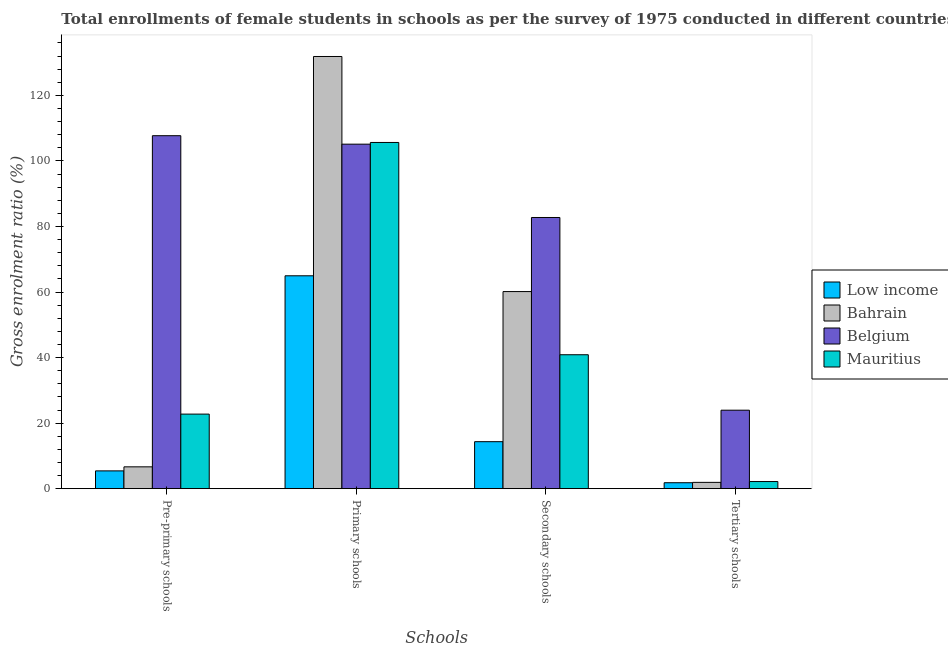How many groups of bars are there?
Give a very brief answer. 4. How many bars are there on the 1st tick from the left?
Your answer should be very brief. 4. How many bars are there on the 3rd tick from the right?
Make the answer very short. 4. What is the label of the 4th group of bars from the left?
Provide a succinct answer. Tertiary schools. What is the gross enrolment ratio(female) in pre-primary schools in Low income?
Make the answer very short. 5.43. Across all countries, what is the maximum gross enrolment ratio(female) in secondary schools?
Provide a succinct answer. 82.74. Across all countries, what is the minimum gross enrolment ratio(female) in secondary schools?
Make the answer very short. 14.34. In which country was the gross enrolment ratio(female) in primary schools maximum?
Provide a short and direct response. Bahrain. What is the total gross enrolment ratio(female) in tertiary schools in the graph?
Make the answer very short. 29.86. What is the difference between the gross enrolment ratio(female) in tertiary schools in Belgium and that in Bahrain?
Give a very brief answer. 22.02. What is the difference between the gross enrolment ratio(female) in pre-primary schools in Bahrain and the gross enrolment ratio(female) in primary schools in Belgium?
Your answer should be compact. -98.44. What is the average gross enrolment ratio(female) in pre-primary schools per country?
Your answer should be compact. 35.63. What is the difference between the gross enrolment ratio(female) in tertiary schools and gross enrolment ratio(female) in primary schools in Bahrain?
Provide a short and direct response. -129.93. In how many countries, is the gross enrolment ratio(female) in secondary schools greater than 12 %?
Provide a short and direct response. 4. What is the ratio of the gross enrolment ratio(female) in primary schools in Bahrain to that in Low income?
Keep it short and to the point. 2.03. Is the gross enrolment ratio(female) in tertiary schools in Mauritius less than that in Bahrain?
Provide a short and direct response. No. Is the difference between the gross enrolment ratio(female) in pre-primary schools in Mauritius and Low income greater than the difference between the gross enrolment ratio(female) in tertiary schools in Mauritius and Low income?
Provide a succinct answer. Yes. What is the difference between the highest and the second highest gross enrolment ratio(female) in secondary schools?
Give a very brief answer. 22.6. What is the difference between the highest and the lowest gross enrolment ratio(female) in secondary schools?
Offer a very short reply. 68.4. Is it the case that in every country, the sum of the gross enrolment ratio(female) in secondary schools and gross enrolment ratio(female) in primary schools is greater than the sum of gross enrolment ratio(female) in pre-primary schools and gross enrolment ratio(female) in tertiary schools?
Your answer should be very brief. Yes. What does the 2nd bar from the left in Secondary schools represents?
Give a very brief answer. Bahrain. What does the 3rd bar from the right in Secondary schools represents?
Your response must be concise. Bahrain. Is it the case that in every country, the sum of the gross enrolment ratio(female) in pre-primary schools and gross enrolment ratio(female) in primary schools is greater than the gross enrolment ratio(female) in secondary schools?
Make the answer very short. Yes. Does the graph contain any zero values?
Your answer should be very brief. No. Does the graph contain grids?
Ensure brevity in your answer.  No. How many legend labels are there?
Your answer should be very brief. 4. How are the legend labels stacked?
Keep it short and to the point. Vertical. What is the title of the graph?
Ensure brevity in your answer.  Total enrollments of female students in schools as per the survey of 1975 conducted in different countries. What is the label or title of the X-axis?
Your answer should be compact. Schools. What is the Gross enrolment ratio (%) in Low income in Pre-primary schools?
Your answer should be compact. 5.43. What is the Gross enrolment ratio (%) in Bahrain in Pre-primary schools?
Make the answer very short. 6.66. What is the Gross enrolment ratio (%) of Belgium in Pre-primary schools?
Provide a short and direct response. 107.69. What is the Gross enrolment ratio (%) in Mauritius in Pre-primary schools?
Provide a succinct answer. 22.75. What is the Gross enrolment ratio (%) in Low income in Primary schools?
Make the answer very short. 64.95. What is the Gross enrolment ratio (%) in Bahrain in Primary schools?
Make the answer very short. 131.85. What is the Gross enrolment ratio (%) of Belgium in Primary schools?
Offer a terse response. 105.11. What is the Gross enrolment ratio (%) in Mauritius in Primary schools?
Ensure brevity in your answer.  105.62. What is the Gross enrolment ratio (%) in Low income in Secondary schools?
Offer a terse response. 14.34. What is the Gross enrolment ratio (%) of Bahrain in Secondary schools?
Keep it short and to the point. 60.14. What is the Gross enrolment ratio (%) in Belgium in Secondary schools?
Provide a succinct answer. 82.74. What is the Gross enrolment ratio (%) of Mauritius in Secondary schools?
Keep it short and to the point. 40.86. What is the Gross enrolment ratio (%) of Low income in Tertiary schools?
Offer a very short reply. 1.82. What is the Gross enrolment ratio (%) of Bahrain in Tertiary schools?
Keep it short and to the point. 1.92. What is the Gross enrolment ratio (%) of Belgium in Tertiary schools?
Your response must be concise. 23.95. What is the Gross enrolment ratio (%) of Mauritius in Tertiary schools?
Offer a terse response. 2.18. Across all Schools, what is the maximum Gross enrolment ratio (%) in Low income?
Offer a very short reply. 64.95. Across all Schools, what is the maximum Gross enrolment ratio (%) of Bahrain?
Your response must be concise. 131.85. Across all Schools, what is the maximum Gross enrolment ratio (%) in Belgium?
Ensure brevity in your answer.  107.69. Across all Schools, what is the maximum Gross enrolment ratio (%) of Mauritius?
Your response must be concise. 105.62. Across all Schools, what is the minimum Gross enrolment ratio (%) in Low income?
Your answer should be compact. 1.82. Across all Schools, what is the minimum Gross enrolment ratio (%) of Bahrain?
Ensure brevity in your answer.  1.92. Across all Schools, what is the minimum Gross enrolment ratio (%) in Belgium?
Your answer should be compact. 23.95. Across all Schools, what is the minimum Gross enrolment ratio (%) in Mauritius?
Provide a succinct answer. 2.18. What is the total Gross enrolment ratio (%) in Low income in the graph?
Ensure brevity in your answer.  86.53. What is the total Gross enrolment ratio (%) in Bahrain in the graph?
Provide a short and direct response. 200.58. What is the total Gross enrolment ratio (%) of Belgium in the graph?
Provide a short and direct response. 319.48. What is the total Gross enrolment ratio (%) of Mauritius in the graph?
Your response must be concise. 171.41. What is the difference between the Gross enrolment ratio (%) of Low income in Pre-primary schools and that in Primary schools?
Make the answer very short. -59.52. What is the difference between the Gross enrolment ratio (%) in Bahrain in Pre-primary schools and that in Primary schools?
Offer a terse response. -125.19. What is the difference between the Gross enrolment ratio (%) in Belgium in Pre-primary schools and that in Primary schools?
Provide a succinct answer. 2.58. What is the difference between the Gross enrolment ratio (%) in Mauritius in Pre-primary schools and that in Primary schools?
Offer a terse response. -82.87. What is the difference between the Gross enrolment ratio (%) in Low income in Pre-primary schools and that in Secondary schools?
Offer a very short reply. -8.91. What is the difference between the Gross enrolment ratio (%) of Bahrain in Pre-primary schools and that in Secondary schools?
Make the answer very short. -53.47. What is the difference between the Gross enrolment ratio (%) in Belgium in Pre-primary schools and that in Secondary schools?
Ensure brevity in your answer.  24.95. What is the difference between the Gross enrolment ratio (%) in Mauritius in Pre-primary schools and that in Secondary schools?
Offer a terse response. -18.11. What is the difference between the Gross enrolment ratio (%) in Low income in Pre-primary schools and that in Tertiary schools?
Your answer should be compact. 3.61. What is the difference between the Gross enrolment ratio (%) of Bahrain in Pre-primary schools and that in Tertiary schools?
Give a very brief answer. 4.74. What is the difference between the Gross enrolment ratio (%) in Belgium in Pre-primary schools and that in Tertiary schools?
Provide a succinct answer. 83.74. What is the difference between the Gross enrolment ratio (%) in Mauritius in Pre-primary schools and that in Tertiary schools?
Your response must be concise. 20.57. What is the difference between the Gross enrolment ratio (%) in Low income in Primary schools and that in Secondary schools?
Your answer should be very brief. 50.61. What is the difference between the Gross enrolment ratio (%) in Bahrain in Primary schools and that in Secondary schools?
Your response must be concise. 71.72. What is the difference between the Gross enrolment ratio (%) of Belgium in Primary schools and that in Secondary schools?
Keep it short and to the point. 22.37. What is the difference between the Gross enrolment ratio (%) of Mauritius in Primary schools and that in Secondary schools?
Provide a succinct answer. 64.76. What is the difference between the Gross enrolment ratio (%) of Low income in Primary schools and that in Tertiary schools?
Your answer should be very brief. 63.13. What is the difference between the Gross enrolment ratio (%) in Bahrain in Primary schools and that in Tertiary schools?
Give a very brief answer. 129.93. What is the difference between the Gross enrolment ratio (%) of Belgium in Primary schools and that in Tertiary schools?
Give a very brief answer. 81.16. What is the difference between the Gross enrolment ratio (%) in Mauritius in Primary schools and that in Tertiary schools?
Your answer should be very brief. 103.45. What is the difference between the Gross enrolment ratio (%) of Low income in Secondary schools and that in Tertiary schools?
Offer a terse response. 12.52. What is the difference between the Gross enrolment ratio (%) of Bahrain in Secondary schools and that in Tertiary schools?
Provide a succinct answer. 58.21. What is the difference between the Gross enrolment ratio (%) of Belgium in Secondary schools and that in Tertiary schools?
Ensure brevity in your answer.  58.79. What is the difference between the Gross enrolment ratio (%) in Mauritius in Secondary schools and that in Tertiary schools?
Your answer should be compact. 38.69. What is the difference between the Gross enrolment ratio (%) in Low income in Pre-primary schools and the Gross enrolment ratio (%) in Bahrain in Primary schools?
Offer a terse response. -126.43. What is the difference between the Gross enrolment ratio (%) in Low income in Pre-primary schools and the Gross enrolment ratio (%) in Belgium in Primary schools?
Make the answer very short. -99.68. What is the difference between the Gross enrolment ratio (%) in Low income in Pre-primary schools and the Gross enrolment ratio (%) in Mauritius in Primary schools?
Your answer should be very brief. -100.19. What is the difference between the Gross enrolment ratio (%) in Bahrain in Pre-primary schools and the Gross enrolment ratio (%) in Belgium in Primary schools?
Keep it short and to the point. -98.44. What is the difference between the Gross enrolment ratio (%) in Bahrain in Pre-primary schools and the Gross enrolment ratio (%) in Mauritius in Primary schools?
Provide a succinct answer. -98.96. What is the difference between the Gross enrolment ratio (%) of Belgium in Pre-primary schools and the Gross enrolment ratio (%) of Mauritius in Primary schools?
Your answer should be compact. 2.06. What is the difference between the Gross enrolment ratio (%) in Low income in Pre-primary schools and the Gross enrolment ratio (%) in Bahrain in Secondary schools?
Keep it short and to the point. -54.71. What is the difference between the Gross enrolment ratio (%) in Low income in Pre-primary schools and the Gross enrolment ratio (%) in Belgium in Secondary schools?
Offer a very short reply. -77.31. What is the difference between the Gross enrolment ratio (%) of Low income in Pre-primary schools and the Gross enrolment ratio (%) of Mauritius in Secondary schools?
Keep it short and to the point. -35.43. What is the difference between the Gross enrolment ratio (%) in Bahrain in Pre-primary schools and the Gross enrolment ratio (%) in Belgium in Secondary schools?
Give a very brief answer. -76.07. What is the difference between the Gross enrolment ratio (%) in Bahrain in Pre-primary schools and the Gross enrolment ratio (%) in Mauritius in Secondary schools?
Ensure brevity in your answer.  -34.2. What is the difference between the Gross enrolment ratio (%) of Belgium in Pre-primary schools and the Gross enrolment ratio (%) of Mauritius in Secondary schools?
Your answer should be very brief. 66.83. What is the difference between the Gross enrolment ratio (%) of Low income in Pre-primary schools and the Gross enrolment ratio (%) of Bahrain in Tertiary schools?
Provide a short and direct response. 3.5. What is the difference between the Gross enrolment ratio (%) of Low income in Pre-primary schools and the Gross enrolment ratio (%) of Belgium in Tertiary schools?
Provide a short and direct response. -18.52. What is the difference between the Gross enrolment ratio (%) of Low income in Pre-primary schools and the Gross enrolment ratio (%) of Mauritius in Tertiary schools?
Offer a very short reply. 3.25. What is the difference between the Gross enrolment ratio (%) of Bahrain in Pre-primary schools and the Gross enrolment ratio (%) of Belgium in Tertiary schools?
Give a very brief answer. -17.28. What is the difference between the Gross enrolment ratio (%) of Bahrain in Pre-primary schools and the Gross enrolment ratio (%) of Mauritius in Tertiary schools?
Your response must be concise. 4.49. What is the difference between the Gross enrolment ratio (%) of Belgium in Pre-primary schools and the Gross enrolment ratio (%) of Mauritius in Tertiary schools?
Provide a succinct answer. 105.51. What is the difference between the Gross enrolment ratio (%) in Low income in Primary schools and the Gross enrolment ratio (%) in Bahrain in Secondary schools?
Give a very brief answer. 4.81. What is the difference between the Gross enrolment ratio (%) in Low income in Primary schools and the Gross enrolment ratio (%) in Belgium in Secondary schools?
Give a very brief answer. -17.79. What is the difference between the Gross enrolment ratio (%) of Low income in Primary schools and the Gross enrolment ratio (%) of Mauritius in Secondary schools?
Offer a terse response. 24.09. What is the difference between the Gross enrolment ratio (%) in Bahrain in Primary schools and the Gross enrolment ratio (%) in Belgium in Secondary schools?
Your response must be concise. 49.12. What is the difference between the Gross enrolment ratio (%) in Bahrain in Primary schools and the Gross enrolment ratio (%) in Mauritius in Secondary schools?
Make the answer very short. 90.99. What is the difference between the Gross enrolment ratio (%) in Belgium in Primary schools and the Gross enrolment ratio (%) in Mauritius in Secondary schools?
Give a very brief answer. 64.24. What is the difference between the Gross enrolment ratio (%) of Low income in Primary schools and the Gross enrolment ratio (%) of Bahrain in Tertiary schools?
Provide a short and direct response. 63.02. What is the difference between the Gross enrolment ratio (%) in Low income in Primary schools and the Gross enrolment ratio (%) in Belgium in Tertiary schools?
Offer a very short reply. 41. What is the difference between the Gross enrolment ratio (%) of Low income in Primary schools and the Gross enrolment ratio (%) of Mauritius in Tertiary schools?
Your response must be concise. 62.77. What is the difference between the Gross enrolment ratio (%) in Bahrain in Primary schools and the Gross enrolment ratio (%) in Belgium in Tertiary schools?
Provide a short and direct response. 107.91. What is the difference between the Gross enrolment ratio (%) of Bahrain in Primary schools and the Gross enrolment ratio (%) of Mauritius in Tertiary schools?
Your response must be concise. 129.68. What is the difference between the Gross enrolment ratio (%) of Belgium in Primary schools and the Gross enrolment ratio (%) of Mauritius in Tertiary schools?
Provide a succinct answer. 102.93. What is the difference between the Gross enrolment ratio (%) of Low income in Secondary schools and the Gross enrolment ratio (%) of Bahrain in Tertiary schools?
Keep it short and to the point. 12.42. What is the difference between the Gross enrolment ratio (%) of Low income in Secondary schools and the Gross enrolment ratio (%) of Belgium in Tertiary schools?
Provide a short and direct response. -9.61. What is the difference between the Gross enrolment ratio (%) in Low income in Secondary schools and the Gross enrolment ratio (%) in Mauritius in Tertiary schools?
Make the answer very short. 12.16. What is the difference between the Gross enrolment ratio (%) of Bahrain in Secondary schools and the Gross enrolment ratio (%) of Belgium in Tertiary schools?
Your answer should be compact. 36.19. What is the difference between the Gross enrolment ratio (%) in Bahrain in Secondary schools and the Gross enrolment ratio (%) in Mauritius in Tertiary schools?
Keep it short and to the point. 57.96. What is the difference between the Gross enrolment ratio (%) of Belgium in Secondary schools and the Gross enrolment ratio (%) of Mauritius in Tertiary schools?
Your response must be concise. 80.56. What is the average Gross enrolment ratio (%) of Low income per Schools?
Keep it short and to the point. 21.63. What is the average Gross enrolment ratio (%) in Bahrain per Schools?
Your answer should be compact. 50.14. What is the average Gross enrolment ratio (%) in Belgium per Schools?
Keep it short and to the point. 79.87. What is the average Gross enrolment ratio (%) of Mauritius per Schools?
Offer a very short reply. 42.85. What is the difference between the Gross enrolment ratio (%) of Low income and Gross enrolment ratio (%) of Bahrain in Pre-primary schools?
Offer a very short reply. -1.24. What is the difference between the Gross enrolment ratio (%) of Low income and Gross enrolment ratio (%) of Belgium in Pre-primary schools?
Keep it short and to the point. -102.26. What is the difference between the Gross enrolment ratio (%) of Low income and Gross enrolment ratio (%) of Mauritius in Pre-primary schools?
Provide a succinct answer. -17.32. What is the difference between the Gross enrolment ratio (%) of Bahrain and Gross enrolment ratio (%) of Belgium in Pre-primary schools?
Provide a succinct answer. -101.02. What is the difference between the Gross enrolment ratio (%) of Bahrain and Gross enrolment ratio (%) of Mauritius in Pre-primary schools?
Offer a terse response. -16.08. What is the difference between the Gross enrolment ratio (%) in Belgium and Gross enrolment ratio (%) in Mauritius in Pre-primary schools?
Provide a short and direct response. 84.94. What is the difference between the Gross enrolment ratio (%) in Low income and Gross enrolment ratio (%) in Bahrain in Primary schools?
Ensure brevity in your answer.  -66.91. What is the difference between the Gross enrolment ratio (%) of Low income and Gross enrolment ratio (%) of Belgium in Primary schools?
Make the answer very short. -40.16. What is the difference between the Gross enrolment ratio (%) of Low income and Gross enrolment ratio (%) of Mauritius in Primary schools?
Provide a short and direct response. -40.68. What is the difference between the Gross enrolment ratio (%) in Bahrain and Gross enrolment ratio (%) in Belgium in Primary schools?
Provide a short and direct response. 26.75. What is the difference between the Gross enrolment ratio (%) of Bahrain and Gross enrolment ratio (%) of Mauritius in Primary schools?
Provide a succinct answer. 26.23. What is the difference between the Gross enrolment ratio (%) in Belgium and Gross enrolment ratio (%) in Mauritius in Primary schools?
Keep it short and to the point. -0.52. What is the difference between the Gross enrolment ratio (%) of Low income and Gross enrolment ratio (%) of Bahrain in Secondary schools?
Ensure brevity in your answer.  -45.8. What is the difference between the Gross enrolment ratio (%) of Low income and Gross enrolment ratio (%) of Belgium in Secondary schools?
Offer a terse response. -68.4. What is the difference between the Gross enrolment ratio (%) of Low income and Gross enrolment ratio (%) of Mauritius in Secondary schools?
Give a very brief answer. -26.52. What is the difference between the Gross enrolment ratio (%) of Bahrain and Gross enrolment ratio (%) of Belgium in Secondary schools?
Provide a short and direct response. -22.6. What is the difference between the Gross enrolment ratio (%) in Bahrain and Gross enrolment ratio (%) in Mauritius in Secondary schools?
Offer a very short reply. 19.27. What is the difference between the Gross enrolment ratio (%) in Belgium and Gross enrolment ratio (%) in Mauritius in Secondary schools?
Your answer should be compact. 41.87. What is the difference between the Gross enrolment ratio (%) in Low income and Gross enrolment ratio (%) in Bahrain in Tertiary schools?
Your response must be concise. -0.11. What is the difference between the Gross enrolment ratio (%) of Low income and Gross enrolment ratio (%) of Belgium in Tertiary schools?
Ensure brevity in your answer.  -22.13. What is the difference between the Gross enrolment ratio (%) in Low income and Gross enrolment ratio (%) in Mauritius in Tertiary schools?
Give a very brief answer. -0.36. What is the difference between the Gross enrolment ratio (%) of Bahrain and Gross enrolment ratio (%) of Belgium in Tertiary schools?
Make the answer very short. -22.02. What is the difference between the Gross enrolment ratio (%) in Bahrain and Gross enrolment ratio (%) in Mauritius in Tertiary schools?
Your answer should be compact. -0.25. What is the difference between the Gross enrolment ratio (%) in Belgium and Gross enrolment ratio (%) in Mauritius in Tertiary schools?
Give a very brief answer. 21.77. What is the ratio of the Gross enrolment ratio (%) in Low income in Pre-primary schools to that in Primary schools?
Give a very brief answer. 0.08. What is the ratio of the Gross enrolment ratio (%) in Bahrain in Pre-primary schools to that in Primary schools?
Make the answer very short. 0.05. What is the ratio of the Gross enrolment ratio (%) of Belgium in Pre-primary schools to that in Primary schools?
Your response must be concise. 1.02. What is the ratio of the Gross enrolment ratio (%) in Mauritius in Pre-primary schools to that in Primary schools?
Provide a succinct answer. 0.22. What is the ratio of the Gross enrolment ratio (%) of Low income in Pre-primary schools to that in Secondary schools?
Provide a short and direct response. 0.38. What is the ratio of the Gross enrolment ratio (%) of Bahrain in Pre-primary schools to that in Secondary schools?
Make the answer very short. 0.11. What is the ratio of the Gross enrolment ratio (%) of Belgium in Pre-primary schools to that in Secondary schools?
Provide a succinct answer. 1.3. What is the ratio of the Gross enrolment ratio (%) of Mauritius in Pre-primary schools to that in Secondary schools?
Your answer should be compact. 0.56. What is the ratio of the Gross enrolment ratio (%) of Low income in Pre-primary schools to that in Tertiary schools?
Your answer should be compact. 2.99. What is the ratio of the Gross enrolment ratio (%) in Bahrain in Pre-primary schools to that in Tertiary schools?
Your answer should be compact. 3.46. What is the ratio of the Gross enrolment ratio (%) in Belgium in Pre-primary schools to that in Tertiary schools?
Offer a very short reply. 4.5. What is the ratio of the Gross enrolment ratio (%) in Mauritius in Pre-primary schools to that in Tertiary schools?
Your answer should be very brief. 10.46. What is the ratio of the Gross enrolment ratio (%) of Low income in Primary schools to that in Secondary schools?
Your answer should be compact. 4.53. What is the ratio of the Gross enrolment ratio (%) of Bahrain in Primary schools to that in Secondary schools?
Your answer should be very brief. 2.19. What is the ratio of the Gross enrolment ratio (%) in Belgium in Primary schools to that in Secondary schools?
Give a very brief answer. 1.27. What is the ratio of the Gross enrolment ratio (%) in Mauritius in Primary schools to that in Secondary schools?
Give a very brief answer. 2.58. What is the ratio of the Gross enrolment ratio (%) in Low income in Primary schools to that in Tertiary schools?
Your answer should be very brief. 35.74. What is the ratio of the Gross enrolment ratio (%) in Bahrain in Primary schools to that in Tertiary schools?
Offer a very short reply. 68.51. What is the ratio of the Gross enrolment ratio (%) of Belgium in Primary schools to that in Tertiary schools?
Provide a succinct answer. 4.39. What is the ratio of the Gross enrolment ratio (%) in Mauritius in Primary schools to that in Tertiary schools?
Make the answer very short. 48.56. What is the ratio of the Gross enrolment ratio (%) of Low income in Secondary schools to that in Tertiary schools?
Offer a very short reply. 7.89. What is the ratio of the Gross enrolment ratio (%) of Bahrain in Secondary schools to that in Tertiary schools?
Make the answer very short. 31.25. What is the ratio of the Gross enrolment ratio (%) of Belgium in Secondary schools to that in Tertiary schools?
Make the answer very short. 3.46. What is the ratio of the Gross enrolment ratio (%) of Mauritius in Secondary schools to that in Tertiary schools?
Your answer should be compact. 18.79. What is the difference between the highest and the second highest Gross enrolment ratio (%) in Low income?
Keep it short and to the point. 50.61. What is the difference between the highest and the second highest Gross enrolment ratio (%) of Bahrain?
Give a very brief answer. 71.72. What is the difference between the highest and the second highest Gross enrolment ratio (%) of Belgium?
Ensure brevity in your answer.  2.58. What is the difference between the highest and the second highest Gross enrolment ratio (%) in Mauritius?
Ensure brevity in your answer.  64.76. What is the difference between the highest and the lowest Gross enrolment ratio (%) of Low income?
Your answer should be compact. 63.13. What is the difference between the highest and the lowest Gross enrolment ratio (%) of Bahrain?
Your answer should be very brief. 129.93. What is the difference between the highest and the lowest Gross enrolment ratio (%) in Belgium?
Your response must be concise. 83.74. What is the difference between the highest and the lowest Gross enrolment ratio (%) in Mauritius?
Make the answer very short. 103.45. 